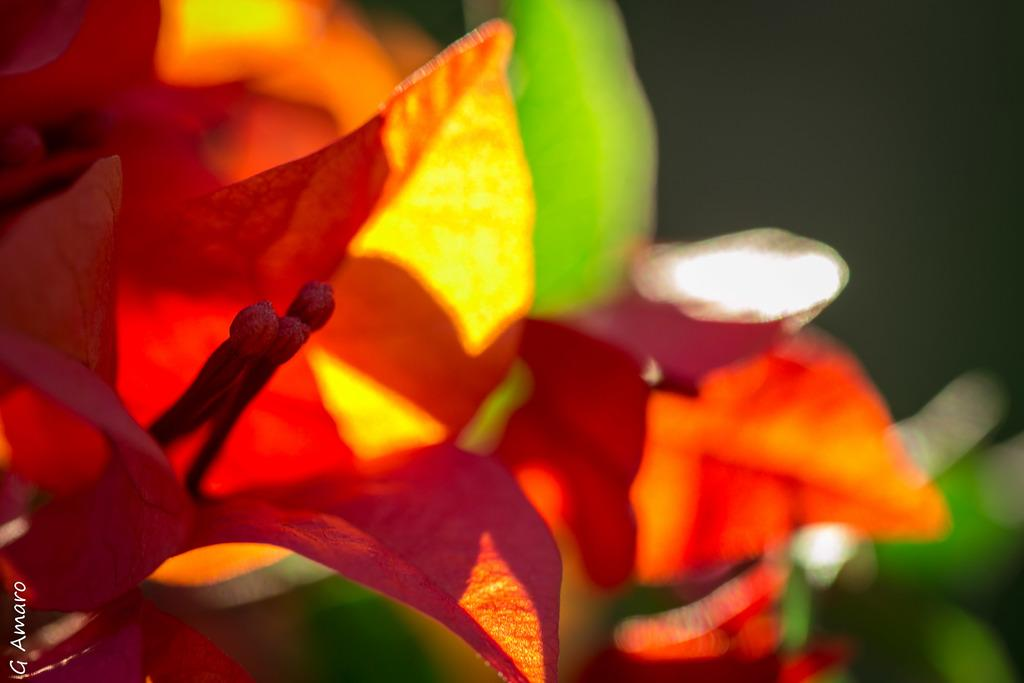What type of vegetation can be seen in the image? There are leaves in the image. Where is the text located in the image? The text is at the bottom left corner of the image. What type of quiver is present in the image? There is no quiver present in the image. How does the nerve affect the image? There is no mention of a nerve in the image, so it cannot affect the image. 